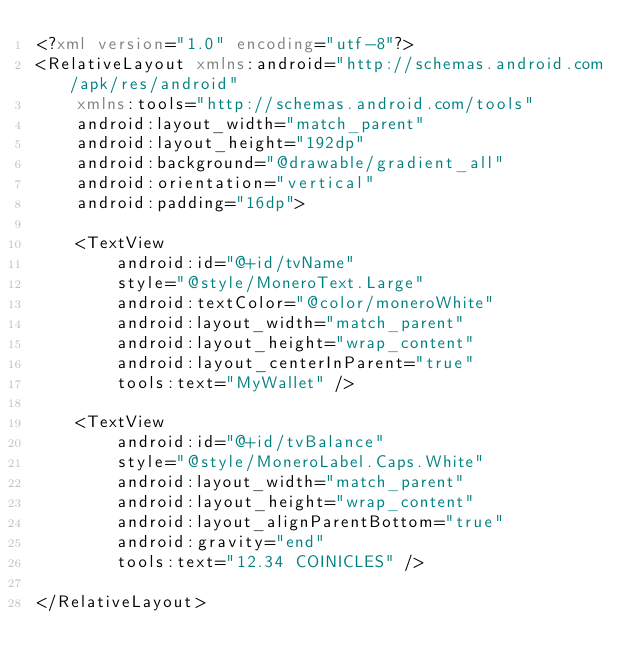Convert code to text. <code><loc_0><loc_0><loc_500><loc_500><_XML_><?xml version="1.0" encoding="utf-8"?>
<RelativeLayout xmlns:android="http://schemas.android.com/apk/res/android"
    xmlns:tools="http://schemas.android.com/tools"
    android:layout_width="match_parent"
    android:layout_height="192dp"
    android:background="@drawable/gradient_all"
    android:orientation="vertical"
    android:padding="16dp">

    <TextView
        android:id="@+id/tvName"
        style="@style/MoneroText.Large"
        android:textColor="@color/moneroWhite"
        android:layout_width="match_parent"
        android:layout_height="wrap_content"
        android:layout_centerInParent="true"
        tools:text="MyWallet" />

    <TextView
        android:id="@+id/tvBalance"
        style="@style/MoneroLabel.Caps.White"
        android:layout_width="match_parent"
        android:layout_height="wrap_content"
        android:layout_alignParentBottom="true"
        android:gravity="end"
        tools:text="12.34 COINICLES" />

</RelativeLayout></code> 